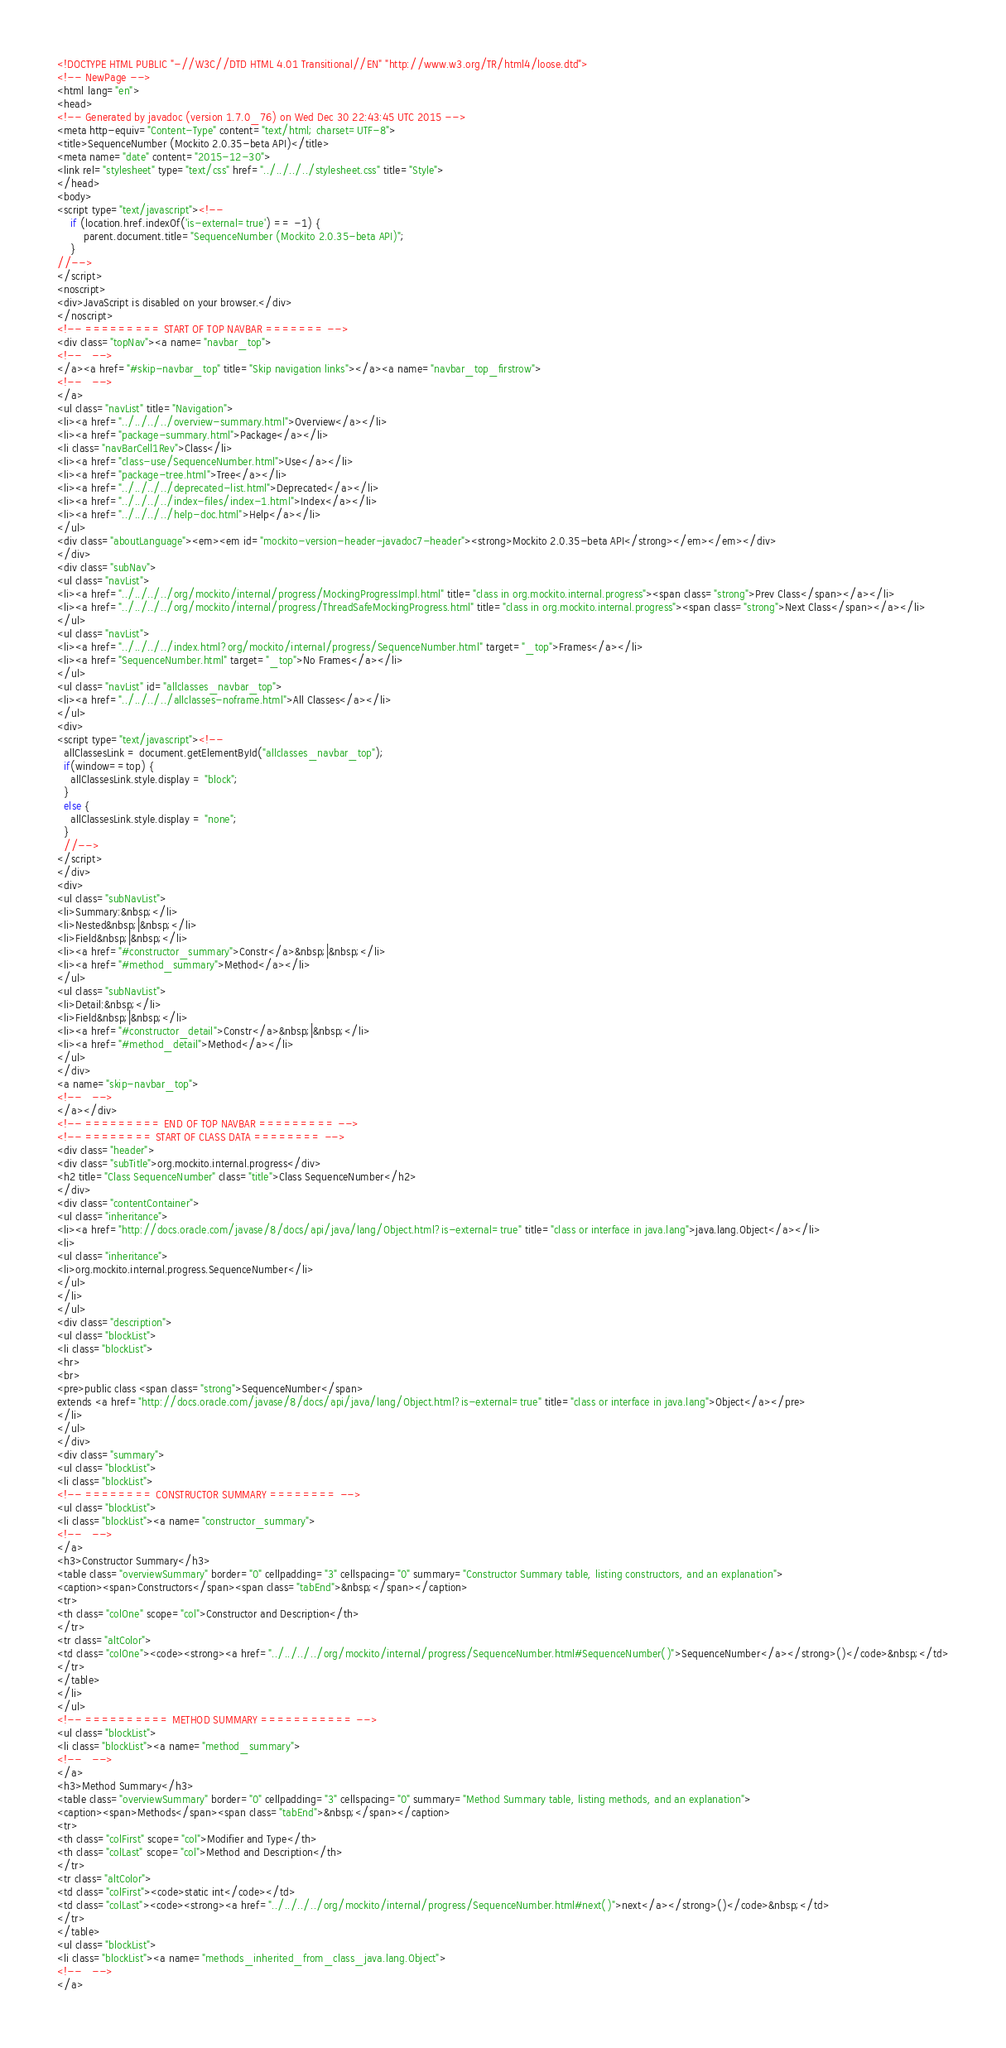Convert code to text. <code><loc_0><loc_0><loc_500><loc_500><_HTML_><!DOCTYPE HTML PUBLIC "-//W3C//DTD HTML 4.01 Transitional//EN" "http://www.w3.org/TR/html4/loose.dtd">
<!-- NewPage -->
<html lang="en">
<head>
<!-- Generated by javadoc (version 1.7.0_76) on Wed Dec 30 22:43:45 UTC 2015 -->
<meta http-equiv="Content-Type" content="text/html; charset=UTF-8">
<title>SequenceNumber (Mockito 2.0.35-beta API)</title>
<meta name="date" content="2015-12-30">
<link rel="stylesheet" type="text/css" href="../../../../stylesheet.css" title="Style">
</head>
<body>
<script type="text/javascript"><!--
    if (location.href.indexOf('is-external=true') == -1) {
        parent.document.title="SequenceNumber (Mockito 2.0.35-beta API)";
    }
//-->
</script>
<noscript>
<div>JavaScript is disabled on your browser.</div>
</noscript>
<!-- ========= START OF TOP NAVBAR ======= -->
<div class="topNav"><a name="navbar_top">
<!--   -->
</a><a href="#skip-navbar_top" title="Skip navigation links"></a><a name="navbar_top_firstrow">
<!--   -->
</a>
<ul class="navList" title="Navigation">
<li><a href="../../../../overview-summary.html">Overview</a></li>
<li><a href="package-summary.html">Package</a></li>
<li class="navBarCell1Rev">Class</li>
<li><a href="class-use/SequenceNumber.html">Use</a></li>
<li><a href="package-tree.html">Tree</a></li>
<li><a href="../../../../deprecated-list.html">Deprecated</a></li>
<li><a href="../../../../index-files/index-1.html">Index</a></li>
<li><a href="../../../../help-doc.html">Help</a></li>
</ul>
<div class="aboutLanguage"><em><em id="mockito-version-header-javadoc7-header"><strong>Mockito 2.0.35-beta API</strong></em></em></div>
</div>
<div class="subNav">
<ul class="navList">
<li><a href="../../../../org/mockito/internal/progress/MockingProgressImpl.html" title="class in org.mockito.internal.progress"><span class="strong">Prev Class</span></a></li>
<li><a href="../../../../org/mockito/internal/progress/ThreadSafeMockingProgress.html" title="class in org.mockito.internal.progress"><span class="strong">Next Class</span></a></li>
</ul>
<ul class="navList">
<li><a href="../../../../index.html?org/mockito/internal/progress/SequenceNumber.html" target="_top">Frames</a></li>
<li><a href="SequenceNumber.html" target="_top">No Frames</a></li>
</ul>
<ul class="navList" id="allclasses_navbar_top">
<li><a href="../../../../allclasses-noframe.html">All Classes</a></li>
</ul>
<div>
<script type="text/javascript"><!--
  allClassesLink = document.getElementById("allclasses_navbar_top");
  if(window==top) {
    allClassesLink.style.display = "block";
  }
  else {
    allClassesLink.style.display = "none";
  }
  //-->
</script>
</div>
<div>
<ul class="subNavList">
<li>Summary:&nbsp;</li>
<li>Nested&nbsp;|&nbsp;</li>
<li>Field&nbsp;|&nbsp;</li>
<li><a href="#constructor_summary">Constr</a>&nbsp;|&nbsp;</li>
<li><a href="#method_summary">Method</a></li>
</ul>
<ul class="subNavList">
<li>Detail:&nbsp;</li>
<li>Field&nbsp;|&nbsp;</li>
<li><a href="#constructor_detail">Constr</a>&nbsp;|&nbsp;</li>
<li><a href="#method_detail">Method</a></li>
</ul>
</div>
<a name="skip-navbar_top">
<!--   -->
</a></div>
<!-- ========= END OF TOP NAVBAR ========= -->
<!-- ======== START OF CLASS DATA ======== -->
<div class="header">
<div class="subTitle">org.mockito.internal.progress</div>
<h2 title="Class SequenceNumber" class="title">Class SequenceNumber</h2>
</div>
<div class="contentContainer">
<ul class="inheritance">
<li><a href="http://docs.oracle.com/javase/8/docs/api/java/lang/Object.html?is-external=true" title="class or interface in java.lang">java.lang.Object</a></li>
<li>
<ul class="inheritance">
<li>org.mockito.internal.progress.SequenceNumber</li>
</ul>
</li>
</ul>
<div class="description">
<ul class="blockList">
<li class="blockList">
<hr>
<br>
<pre>public class <span class="strong">SequenceNumber</span>
extends <a href="http://docs.oracle.com/javase/8/docs/api/java/lang/Object.html?is-external=true" title="class or interface in java.lang">Object</a></pre>
</li>
</ul>
</div>
<div class="summary">
<ul class="blockList">
<li class="blockList">
<!-- ======== CONSTRUCTOR SUMMARY ======== -->
<ul class="blockList">
<li class="blockList"><a name="constructor_summary">
<!--   -->
</a>
<h3>Constructor Summary</h3>
<table class="overviewSummary" border="0" cellpadding="3" cellspacing="0" summary="Constructor Summary table, listing constructors, and an explanation">
<caption><span>Constructors</span><span class="tabEnd">&nbsp;</span></caption>
<tr>
<th class="colOne" scope="col">Constructor and Description</th>
</tr>
<tr class="altColor">
<td class="colOne"><code><strong><a href="../../../../org/mockito/internal/progress/SequenceNumber.html#SequenceNumber()">SequenceNumber</a></strong>()</code>&nbsp;</td>
</tr>
</table>
</li>
</ul>
<!-- ========== METHOD SUMMARY =========== -->
<ul class="blockList">
<li class="blockList"><a name="method_summary">
<!--   -->
</a>
<h3>Method Summary</h3>
<table class="overviewSummary" border="0" cellpadding="3" cellspacing="0" summary="Method Summary table, listing methods, and an explanation">
<caption><span>Methods</span><span class="tabEnd">&nbsp;</span></caption>
<tr>
<th class="colFirst" scope="col">Modifier and Type</th>
<th class="colLast" scope="col">Method and Description</th>
</tr>
<tr class="altColor">
<td class="colFirst"><code>static int</code></td>
<td class="colLast"><code><strong><a href="../../../../org/mockito/internal/progress/SequenceNumber.html#next()">next</a></strong>()</code>&nbsp;</td>
</tr>
</table>
<ul class="blockList">
<li class="blockList"><a name="methods_inherited_from_class_java.lang.Object">
<!--   -->
</a></code> 